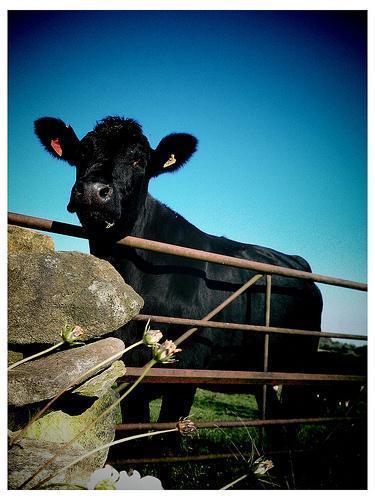How many animals are there?
Give a very brief answer. 1. How many flowers are there?
Give a very brief answer. 5. 